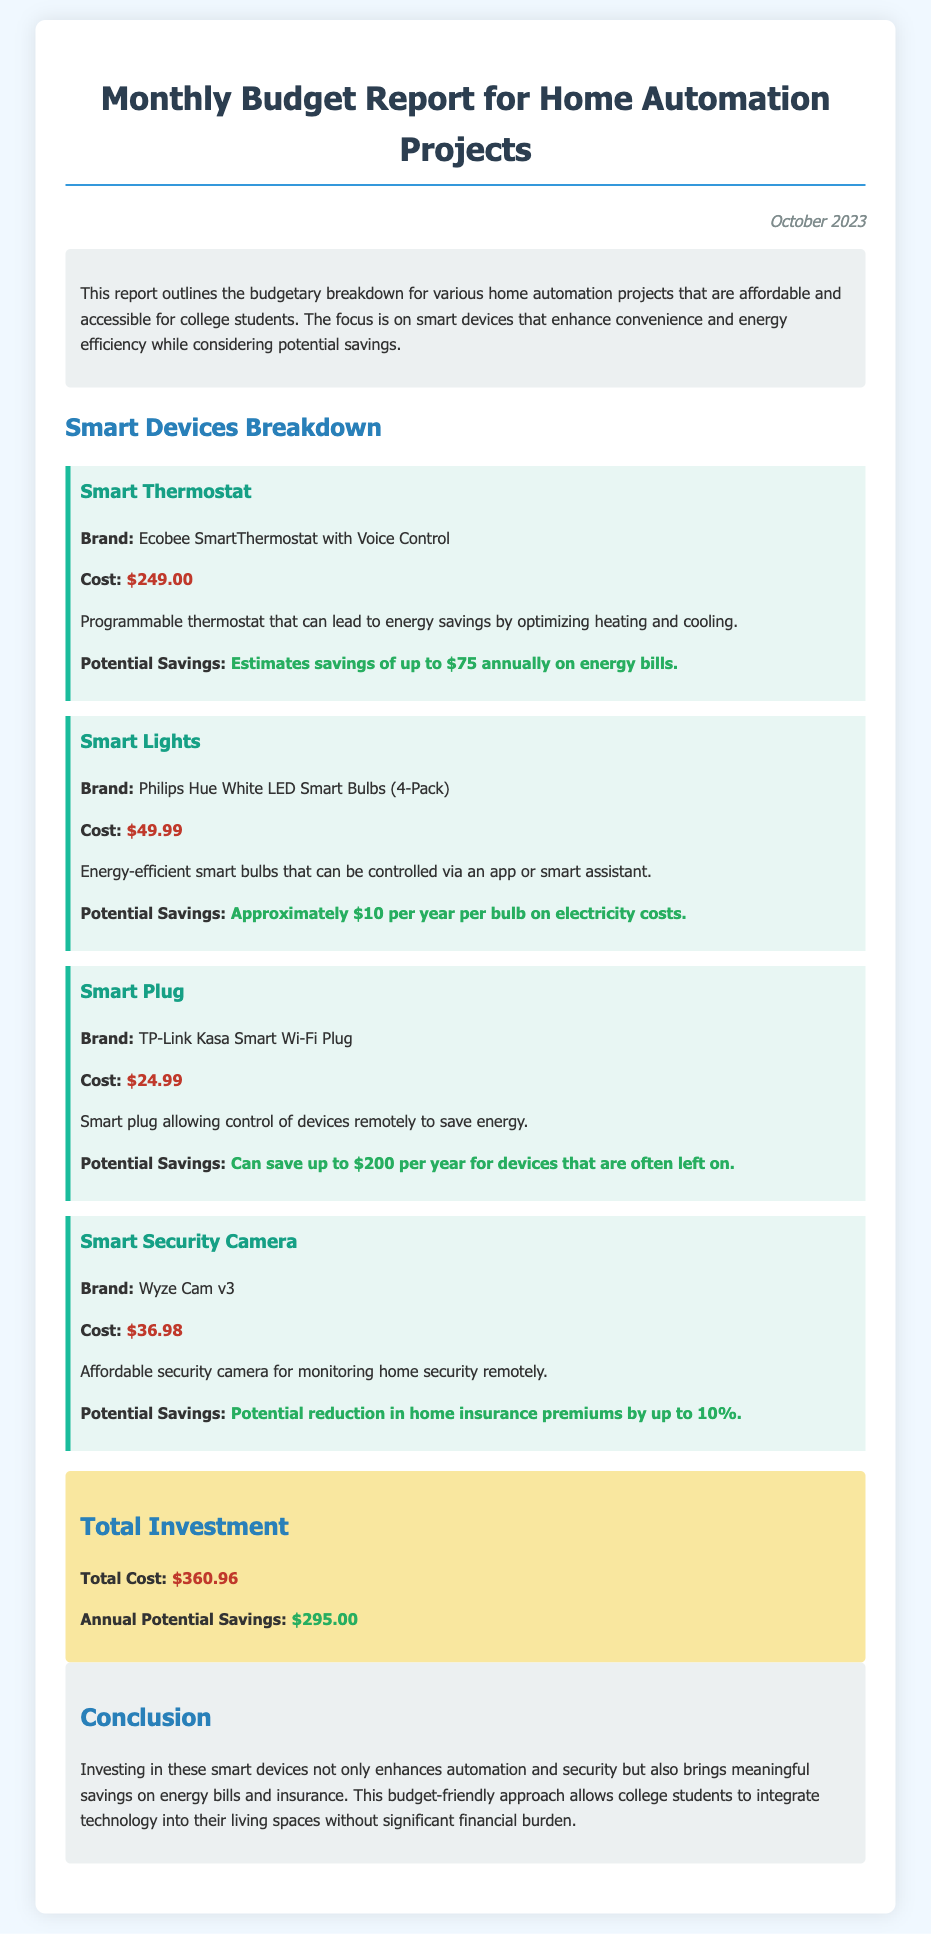What is the total investment? The total investment is detailed in the final section of the report under 'Total Investment,' which sums the costs of all listed smart devices.
Answer: $360.96 What is the brand of the smart thermostat? The brand is provided in the description of the smart thermostat device in the report.
Answer: Ecobee SmartThermostat with Voice Control How much can be saved annually with the smart thermostat? Potential savings are specified in the description of the smart thermostat in terms of energy bill reductions.
Answer: $75 What is the cost of the smart plug? The cost of the smart plug is mentioned directly in its individual section.
Answer: $24.99 What is the potential reduction in home insurance premiums with a smart security camera? The report outlines potential savings in home insurance in relation to the smart security camera.
Answer: 10% What is the potential annual saving from the smart plugs? The smart plug section highlights the potential savings and gives a figure related to energy savings.
Answer: $200 How many Philips Hue smart bulbs are included in the pack? The number of bulbs is specified in the description of the smart lights.
Answer: 4-Pack What is highlighted as a benefit of investing in home automation? The conclusion summarizes the advantages of investing in smart devices, focusing on both convenience and savings.
Answer: Enhanced automation and security What is the monthly budget report date? The date is mentioned at the top of the document, indicating when the report is current.
Answer: October 2023 